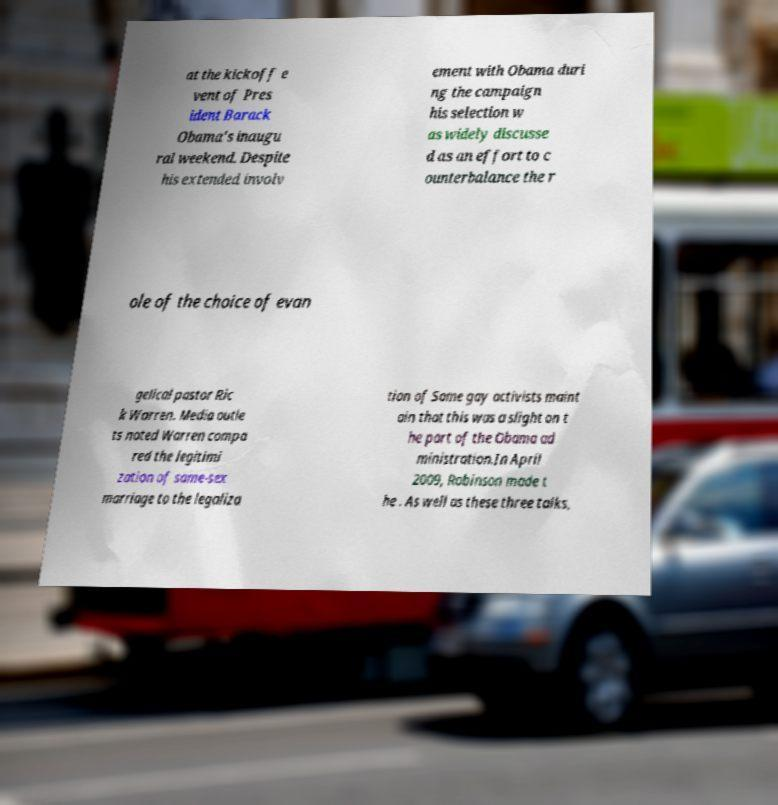I need the written content from this picture converted into text. Can you do that? at the kickoff e vent of Pres ident Barack Obama's inaugu ral weekend. Despite his extended involv ement with Obama duri ng the campaign his selection w as widely discusse d as an effort to c ounterbalance the r ole of the choice of evan gelical pastor Ric k Warren. Media outle ts noted Warren compa red the legitimi zation of same-sex marriage to the legaliza tion of Some gay activists maint ain that this was a slight on t he part of the Obama ad ministration.In April 2009, Robinson made t he . As well as these three talks, 